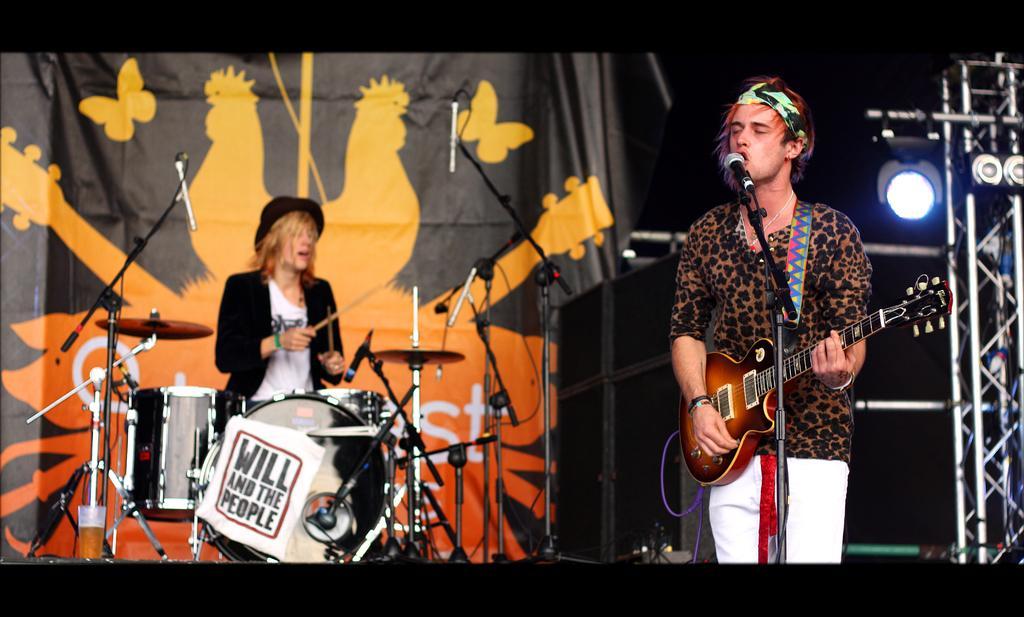Describe this image in one or two sentences. In this image I can see two people. One person is standing in front of the mic and playing guitar. And another one is playing drum set. 